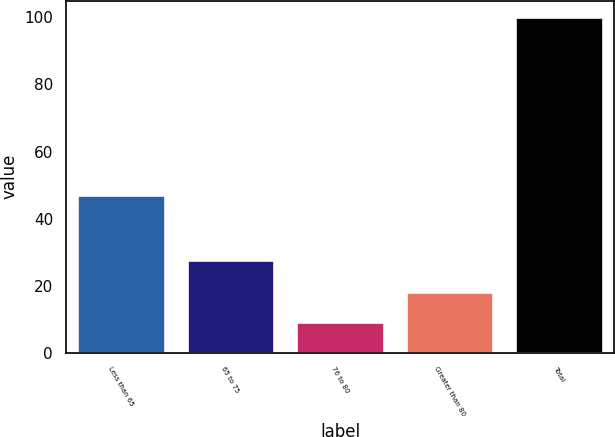Convert chart. <chart><loc_0><loc_0><loc_500><loc_500><bar_chart><fcel>Less than 65<fcel>65 to 75<fcel>76 to 80<fcel>Greater than 80<fcel>Total<nl><fcel>46.9<fcel>27.6<fcel>9.1<fcel>18.19<fcel>100<nl></chart> 